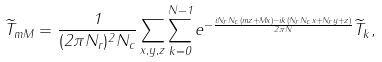<formula> <loc_0><loc_0><loc_500><loc_500>\widetilde { T } _ { m M } = \frac { 1 } { ( 2 \pi N _ { r } ) ^ { 2 } N _ { c } } \sum _ { x , y , z } \sum _ { k = 0 } ^ { N - 1 } e ^ { { - \frac { i N _ { r } N _ { c } ( m z + M x ) - i k ( N _ { r } N _ { c } x + N _ { r } y + z ) } { 2 \pi N } } } \widetilde { T } _ { k } ,</formula> 